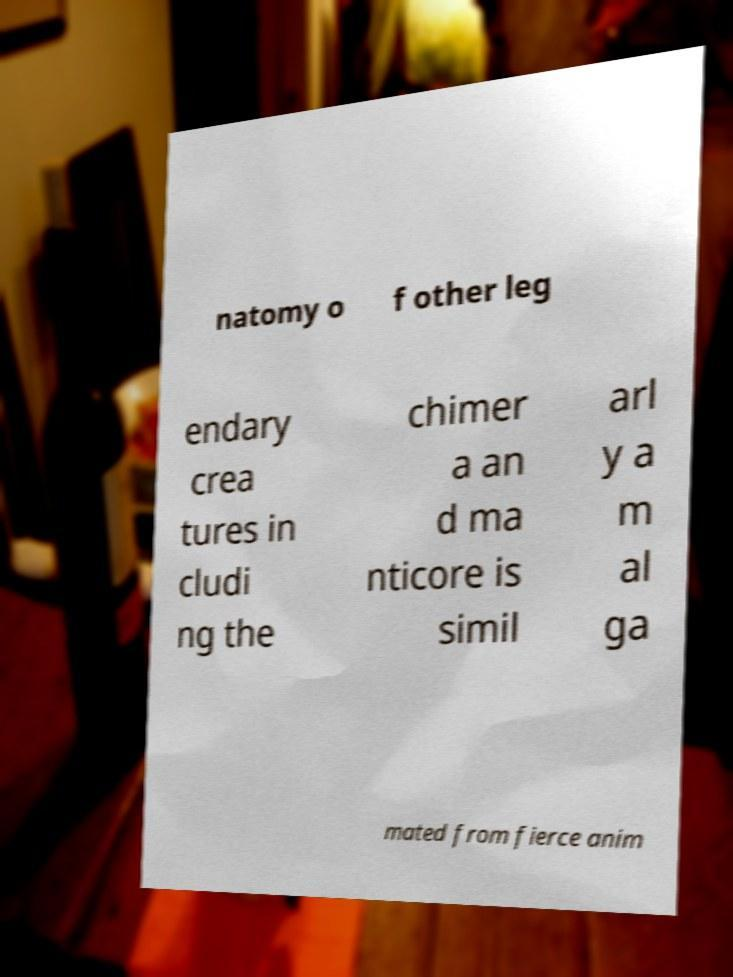What messages or text are displayed in this image? I need them in a readable, typed format. natomy o f other leg endary crea tures in cludi ng the chimer a an d ma nticore is simil arl y a m al ga mated from fierce anim 